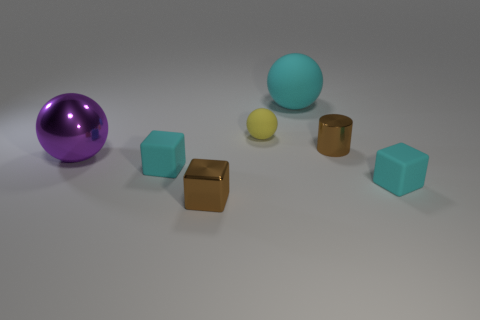Add 3 green metal cubes. How many objects exist? 10 Subtract all cylinders. How many objects are left? 6 Add 5 blue balls. How many blue balls exist? 5 Subtract 0 gray cubes. How many objects are left? 7 Subtract all cylinders. Subtract all yellow rubber balls. How many objects are left? 5 Add 3 big cyan matte balls. How many big cyan matte balls are left? 4 